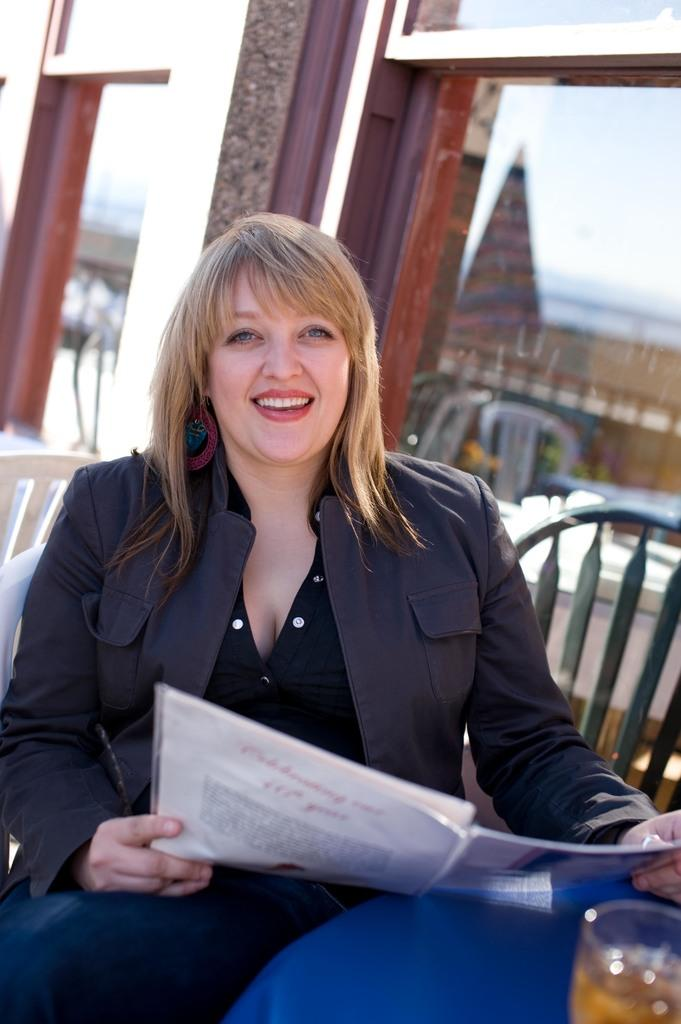Who is present in the image? There is a woman in the image. What is the woman doing in the image? The woman is sitting on a chair and smiling. What is the woman holding in the image? The woman is holding a book. What can be seen on the tables in the image? There are objects on the tables. How many chairs are visible in the image? There are chairs in the image. What is visible in the background of the image? There is a building in the background of the image. What type of chain can be seen hanging from the woman's neck in the image? There is no chain visible around the woman's neck in the image. How many dimes are scattered on the floor in the image? There are no dimes present in the image. 